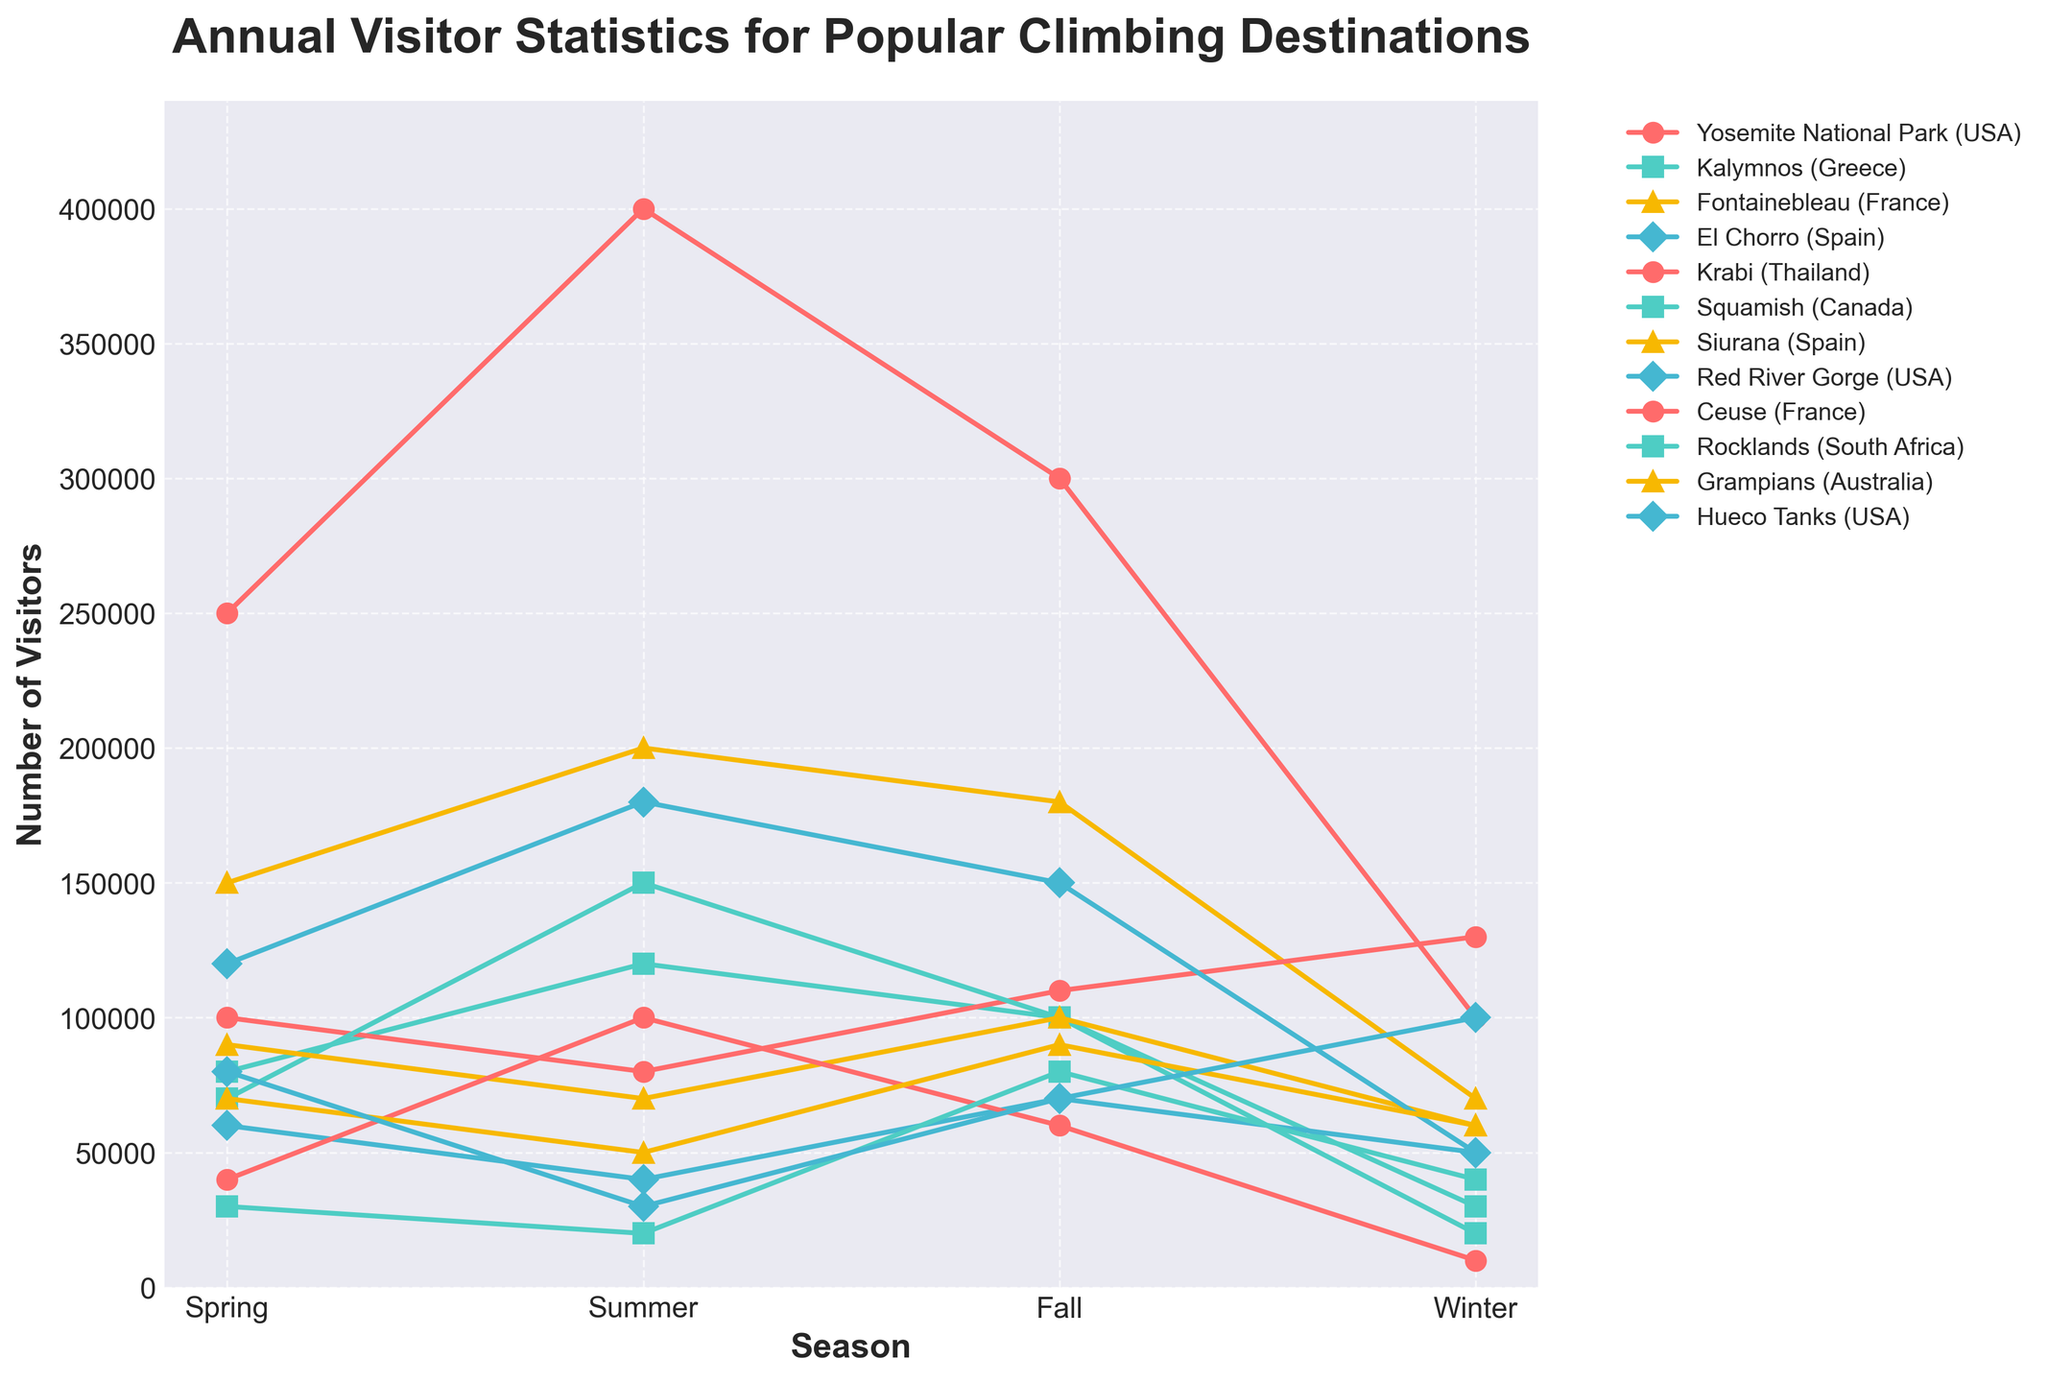Which climbing destination has the highest number of visitors in Summer? By examining the summer visitor counts on the y-axis, we can see that Yosemite National Park (USA) has the highest number of visitors during the summer season.
Answer: Yosemite National Park (USA) Which destination experiences the greatest difference in visitor numbers between Spring and Fall? To determine the greatest difference, we need to calculate the absolute difference between Spring and Fall visitor numbers for each destination and then compare these differences. For Yosemite National Park (USA), the difference is 250,000; for Kalymnos (Greece), it's 20,000; for Fontainebleau (France), it's 30,000; and for El Chorro (Spain), it's 10,000. Krabi (Thailand) shows a difference of 10,000; Squamish (Canada), 30,000; Siurana (Spain), 10,000; Red River Gorge (USA), 30,000; Ceuse (France), 20,000; Rocklands (South Africa), 50,000; Grampians (Australia), 20,000; and Hueco Tanks (USA), the difference is 10,000. The greatest difference is in Yosemite National Park (USA).
Answer: Yosemite National Park (USA) Which two destinations have the closest visitor numbers in Winter? By checking the winter visitor counts, we see that Squamish (Canada) has 20,000 visitors and Ceuse (France) has 10,000 visitors, which are the closest values. However, Siurana (Spain) and Rocklands (South Africa) have 60,000 each, making their visitor counts identical.
Answer: Siurana (Spain) and Rocklands (South Africa) What is the average number of visitors during Fall across all destinations? To find the average, sum all the visitor numbers for Fall and divide by the number of destinations. The sum is 300,000 (Yosemite) + 100,000 (Kalymnos) + 180,000 (Fontainebleau) + 70,000 (El Chorro) + 110,000 (Krabi) + 100,000 (Squamish) + 100,000 (Siurana) + 150,000 (Red River Gorge) + 60,000 (Ceuse), + 80,000 (Rocklands) + 90,000 (Grampians) + 70,000 (Hueco Tanks) = 1,510,000. Dividing by the 12 destinations, the average is 1,510,000 / 12 = 125,833.33.
Answer: 125,833.33 Which season generally attracts the largest number of visitors across all destinations? We sum the visitors for each season across all destinations and compare these sums. Spring total: 850,000; Summer total: 1,310,000; Fall total: 1,510,000; Winter total: 680,000. Fall has the highest visitor count.
Answer: Fall How many more visitors does Yosemite National Park (USA) attract in Summer compared to Winter? Subtract Winter visitors from Summer visitors for Yosemite. 400,000 (Summer) - 100,000 (Winter) = 300,000.
Answer: 300,000 Which destination has the lowest number of visitors in Spring, and how many visitors does it have? By examining the Spring visitor numbers, we find that Ceuse (France) has the lowest number with 40,000 visitors.
Answer: Ceuse (France), 40,000 How does the number of visitors in Winter for Kalymnos (Greece) compare to those for Krabi (Thailand)? Kalymnos (Greece) has 30,000 visitors in Winter while Krabi (Thailand) has 130,000 visitors in Winter. Comparing these, Kalymnos has fewer visitors.
Answer: Kalymnos (Greece) has fewer visitors than Krabi (Thailand) What is the combined total number of visitors for Rocklands (South Africa) in Spring and Fall? Sum the visitor numbers for Rocklands in Spring and Fall. Spring: 30,000 + Fall: 80,000 = 110,000.
Answer: 110,000 